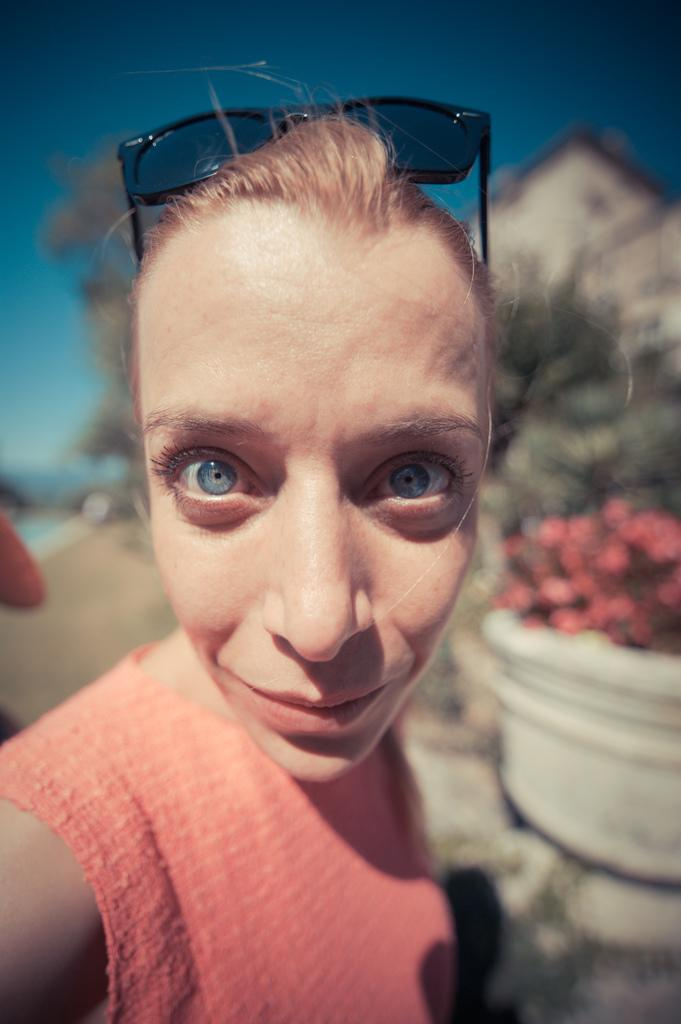Who is present in the image? There is a woman in the image. What type of plants can be seen in the image? There are plants with flowers in a pot in the image. What other natural elements are present in the image? There is a tree in the image. What type of structure is visible in the image? There is a house in the image. Whose hand is visible in the image? A person's hand is visible in the image. How would you describe the weather based on the image? The sky is visible in the image and appears cloudy. What type of sea creatures can be seen in the image? There is no sea or sea creatures present in the image. How does the woman's mind appear in the image? The image does not show the woman's mind; it only shows her physical appearance. 